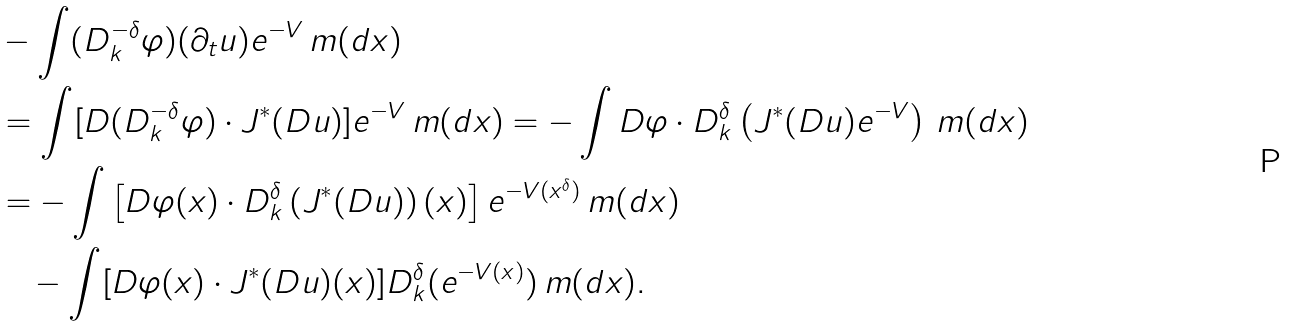Convert formula to latex. <formula><loc_0><loc_0><loc_500><loc_500>& - \int ( D _ { k } ^ { - \delta } \varphi ) ( \partial _ { t } u ) e ^ { - V } \, m ( d x ) \\ & = \int [ D ( D _ { k } ^ { - \delta } \varphi ) \cdot J ^ { * } ( D u ) ] e ^ { - V } \, m ( d x ) = - \int D \varphi \cdot D _ { k } ^ { \delta } \left ( J ^ { * } ( D u ) e ^ { - V } \right ) \, m ( d x ) \\ & = - \int \left [ D \varphi ( x ) \cdot D _ { k } ^ { \delta } \left ( J ^ { * } ( D u ) \right ) ( x ) \right ] e ^ { - V ( x ^ { \delta } ) } \, m ( d x ) \\ & \quad - \int [ D \varphi ( x ) \cdot J ^ { * } ( D u ) ( x ) ] D _ { k } ^ { \delta } ( e ^ { - V ( x ) } ) \, m ( d x ) .</formula> 